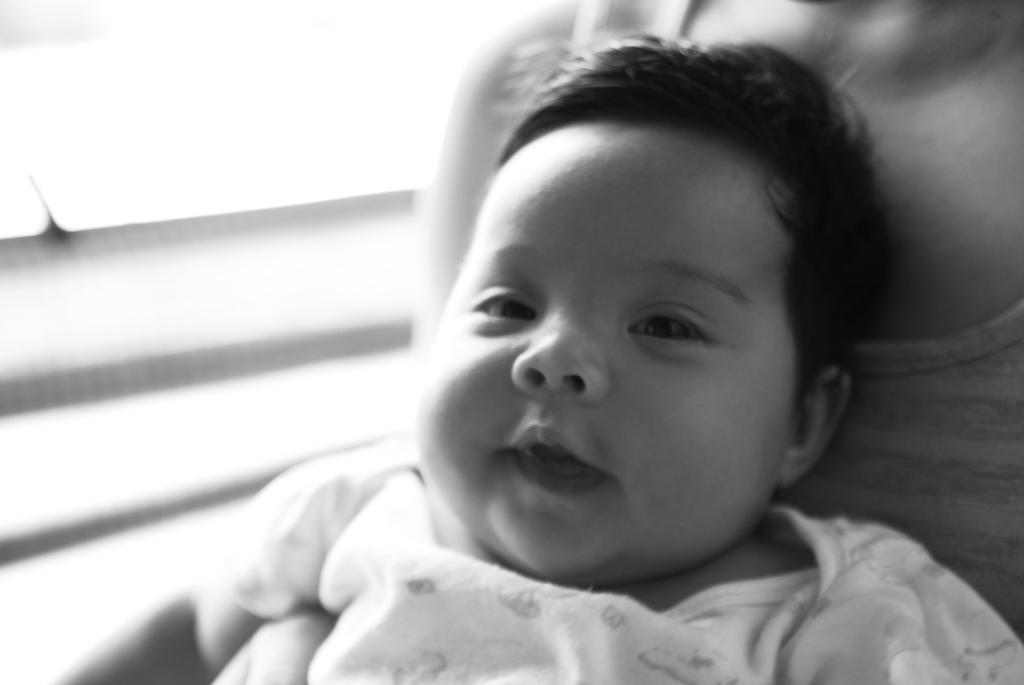What is the color scheme of the image? The image is black and white. What can be seen in the image? There is a baby in the image. Where is the baby located in the image? The baby is in someone's lap. What type of train is visible in the image? There is no train present in the image; it features a black and white image of a baby in someone's lap. What type of work is the baby doing in the image? The baby is not shown doing any work in the image; they are simply sitting in someone's lap. 